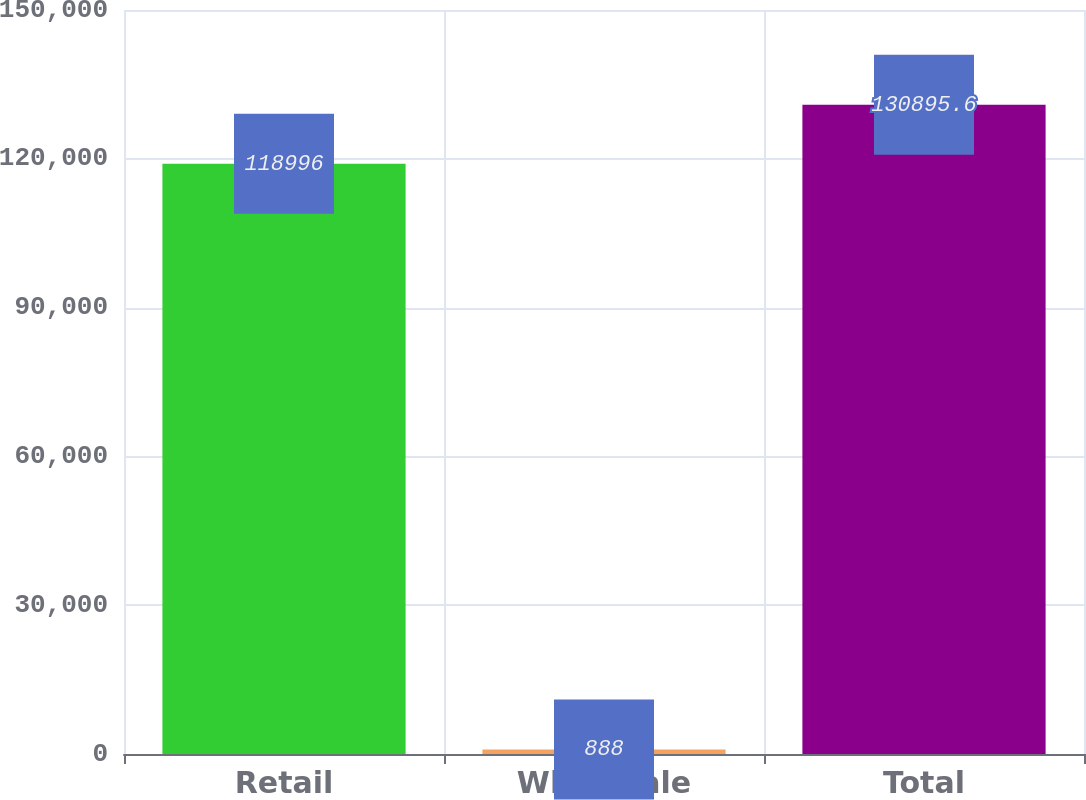<chart> <loc_0><loc_0><loc_500><loc_500><bar_chart><fcel>Retail<fcel>Wholesale<fcel>Total<nl><fcel>118996<fcel>888<fcel>130896<nl></chart> 